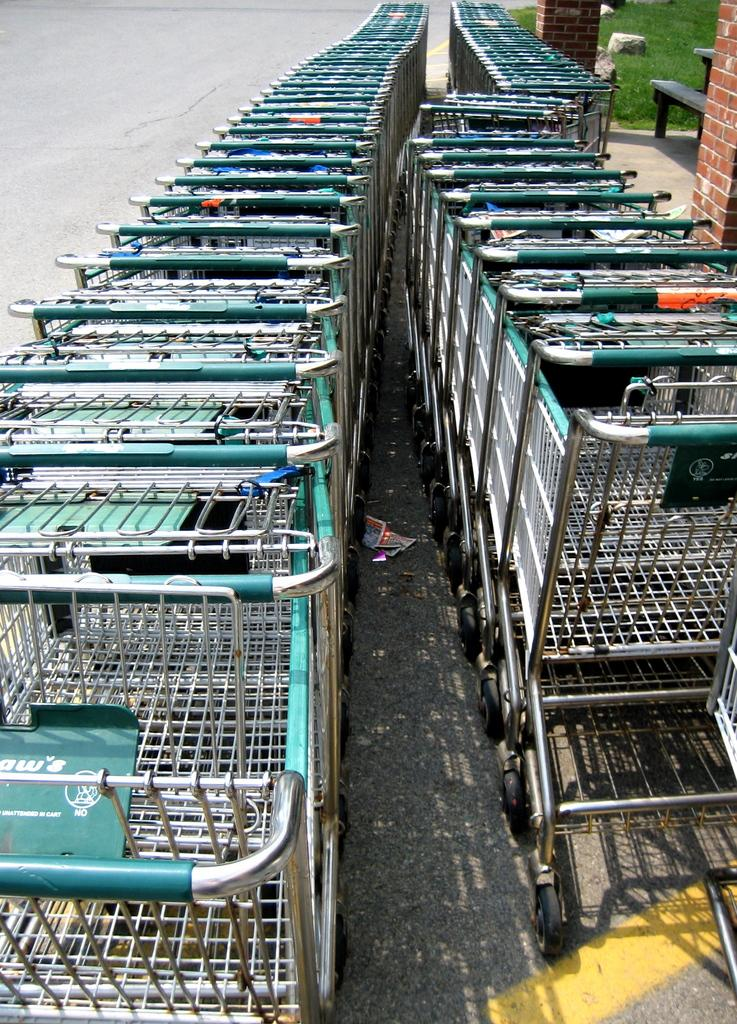Provide a one-sentence caption for the provided image. Shopping carts are lined uo and a sign on the cart says no in white letters. 